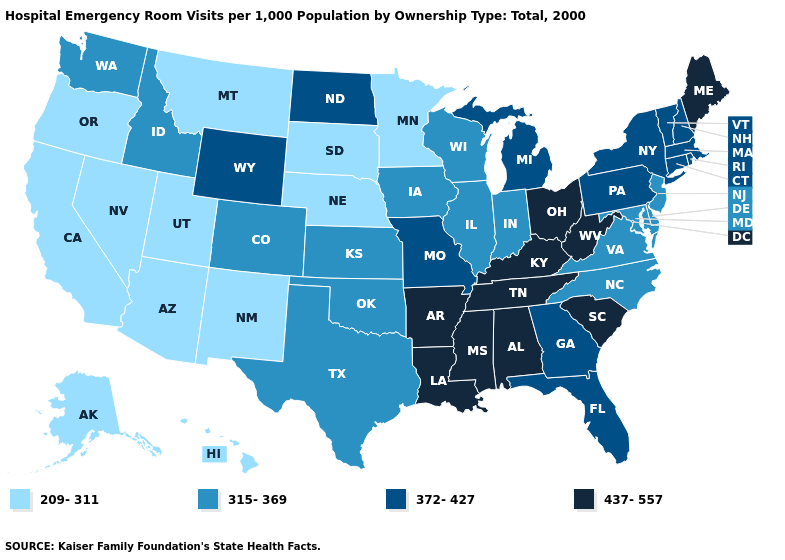Which states have the lowest value in the South?
Short answer required. Delaware, Maryland, North Carolina, Oklahoma, Texas, Virginia. Name the states that have a value in the range 437-557?
Short answer required. Alabama, Arkansas, Kentucky, Louisiana, Maine, Mississippi, Ohio, South Carolina, Tennessee, West Virginia. What is the highest value in the USA?
Write a very short answer. 437-557. What is the highest value in the USA?
Keep it brief. 437-557. What is the value of Illinois?
Short answer required. 315-369. Does the first symbol in the legend represent the smallest category?
Answer briefly. Yes. Among the states that border West Virginia , does Ohio have the lowest value?
Answer briefly. No. Among the states that border Wisconsin , which have the lowest value?
Short answer required. Minnesota. Does Wyoming have the highest value in the West?
Keep it brief. Yes. Which states have the lowest value in the West?
Answer briefly. Alaska, Arizona, California, Hawaii, Montana, Nevada, New Mexico, Oregon, Utah. Does New Jersey have a higher value than Rhode Island?
Concise answer only. No. What is the value of Georgia?
Short answer required. 372-427. What is the lowest value in the South?
Quick response, please. 315-369. Which states have the highest value in the USA?
Be succinct. Alabama, Arkansas, Kentucky, Louisiana, Maine, Mississippi, Ohio, South Carolina, Tennessee, West Virginia. Does Vermont have the same value as Pennsylvania?
Give a very brief answer. Yes. 